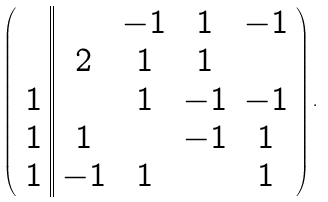Convert formula to latex. <formula><loc_0><loc_0><loc_500><loc_500>\left ( \begin{array} { c | | c c c c } & & - 1 & 1 & - 1 \\ & 2 & 1 & 1 & \\ 1 & & 1 & - 1 & - 1 \\ 1 & 1 & & - 1 & 1 \\ 1 & - 1 & 1 & & 1 \end{array} \right ) .</formula> 